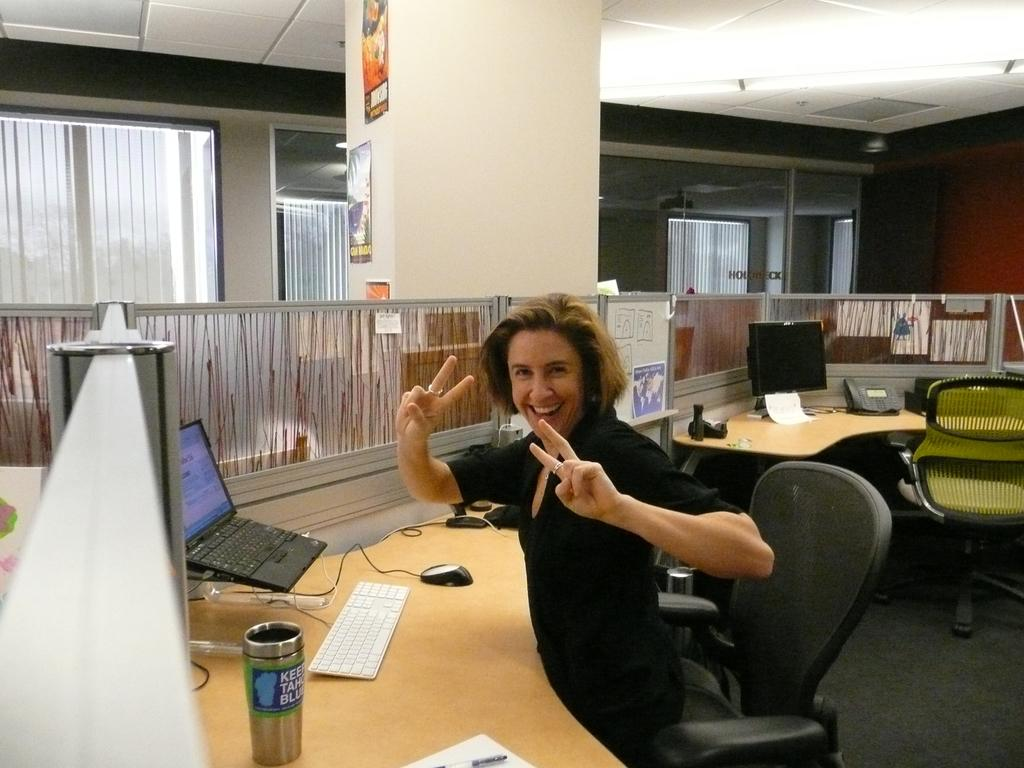Who is the main subject in the image? There is a woman in the image. What is the woman doing in the image? The woman is sitting in front of a table. What objects are on the table in the image? There is a laptop, a keyboard, and a mouse on the table. Where was the image taken? The image was taken inside an office room. How many dogs are visible in the image? There are no dogs present in the image. Is the woman in the image a prisoner? There is no indication in the image that the woman is a prisoner; she is sitting in an office room. 